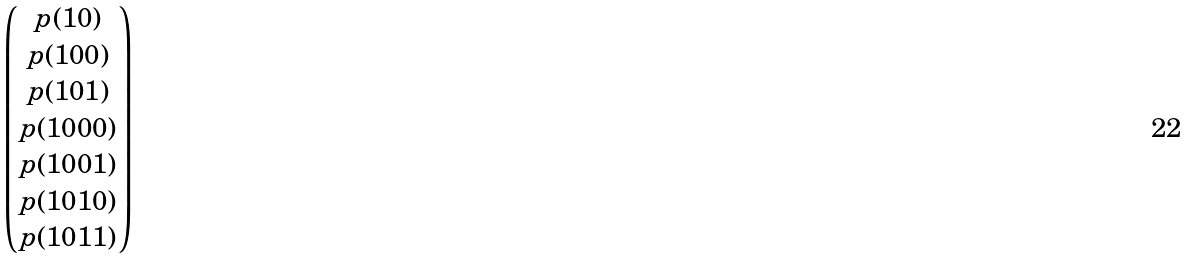Convert formula to latex. <formula><loc_0><loc_0><loc_500><loc_500>\begin{pmatrix} p ( 1 0 ) \\ p ( 1 0 0 ) \\ p ( 1 0 1 ) \\ p ( 1 0 0 0 ) \\ p ( 1 0 0 1 ) \\ p ( 1 0 1 0 ) \\ p ( 1 0 1 1 ) \\ \end{pmatrix}</formula> 